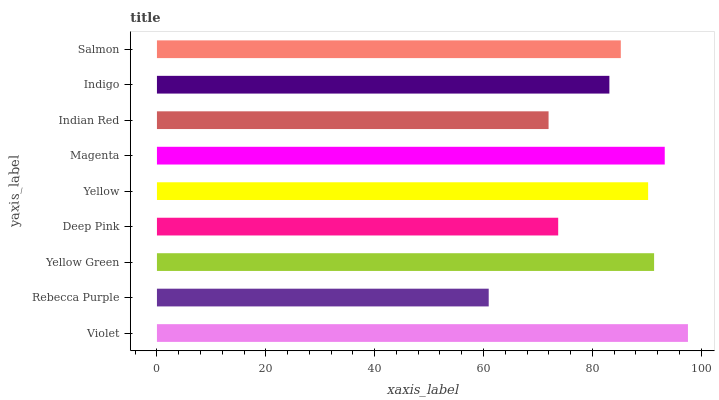Is Rebecca Purple the minimum?
Answer yes or no. Yes. Is Violet the maximum?
Answer yes or no. Yes. Is Yellow Green the minimum?
Answer yes or no. No. Is Yellow Green the maximum?
Answer yes or no. No. Is Yellow Green greater than Rebecca Purple?
Answer yes or no. Yes. Is Rebecca Purple less than Yellow Green?
Answer yes or no. Yes. Is Rebecca Purple greater than Yellow Green?
Answer yes or no. No. Is Yellow Green less than Rebecca Purple?
Answer yes or no. No. Is Salmon the high median?
Answer yes or no. Yes. Is Salmon the low median?
Answer yes or no. Yes. Is Rebecca Purple the high median?
Answer yes or no. No. Is Magenta the low median?
Answer yes or no. No. 